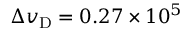<formula> <loc_0><loc_0><loc_500><loc_500>\Delta v _ { D } = 0 . 2 7 \times 1 0 ^ { 5 }</formula> 